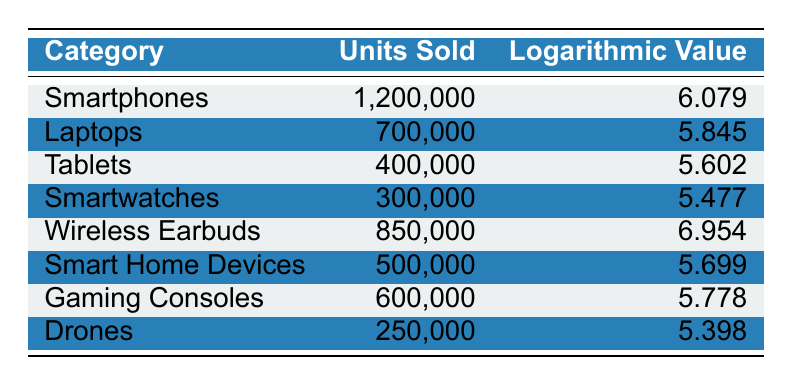What is the category with the highest units sold? From the table, "Smartphones" has the highest units sold, totaling 1,200,000.
Answer: Smartphones How many units were sold in the "Wireless Earbuds" category? The table shows that "Wireless Earbuds" had 850,000 units sold.
Answer: 850,000 What is the difference in units sold between "Smartphones" and "Tablets"? The units sold for "Smartphones" is 1,200,000 and for "Tablets" it's 400,000. The difference is 1,200,000 - 400,000 = 800,000.
Answer: 800,000 Is the logarithmic value for "Gaming Consoles" greater than that for "Smart Home Devices"? The logarithmic value for "Gaming Consoles" is 5.778, while for "Smart Home Devices" it is 5.699. Since 5.778 > 5.699, the statement is true.
Answer: Yes What is the average logarithmic value of "Smartwatches" and "Drones"? The logarithmic values are 5.477 for "Smartwatches" and 5.398 for "Drones." Adding these gives 5.477 + 5.398 = 10.875, and dividing by 2 gives an average of 10.875 / 2 = 5.4375.
Answer: 5.4375 Which categories sold more than 600,000 units? Referring to the table, "Smartphones" (1,200,000) and "Wireless Earbuds" (850,000) sold more than 600,000 units.
Answer: Smartphones, Wireless Earbuds What is the total number of units sold across all categories listed? To find the total, sum up all units sold: 1,200,000 + 700,000 + 400,000 + 300,000 + 850,000 + 500,000 + 600,000 + 250,000 = 4,800,000.
Answer: 4,800,000 Is it true that "Tablets" have a logarithmic value greater than "Drones"? The logarithmic value for "Tablets" is 5.602 and for "Drones" is 5.398. Since 5.602 > 5.398, it is true.
Answer: Yes What is the category with the lowest logarithmic value? The lowest logarithmic value in the table is for "Drones," which has a value of 5.398.
Answer: Drones 